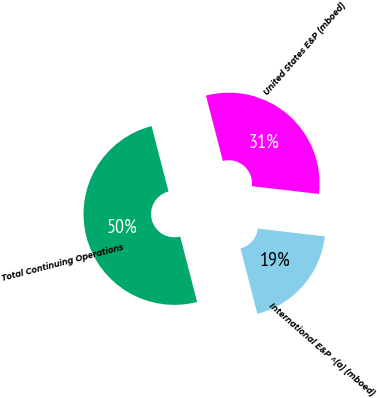Convert chart to OTSL. <chart><loc_0><loc_0><loc_500><loc_500><pie_chart><fcel>United States E&P (mboed)<fcel>International E&P ^(a) (mboed)<fcel>Total Continuing Operations<nl><fcel>30.87%<fcel>19.13%<fcel>50.0%<nl></chart> 